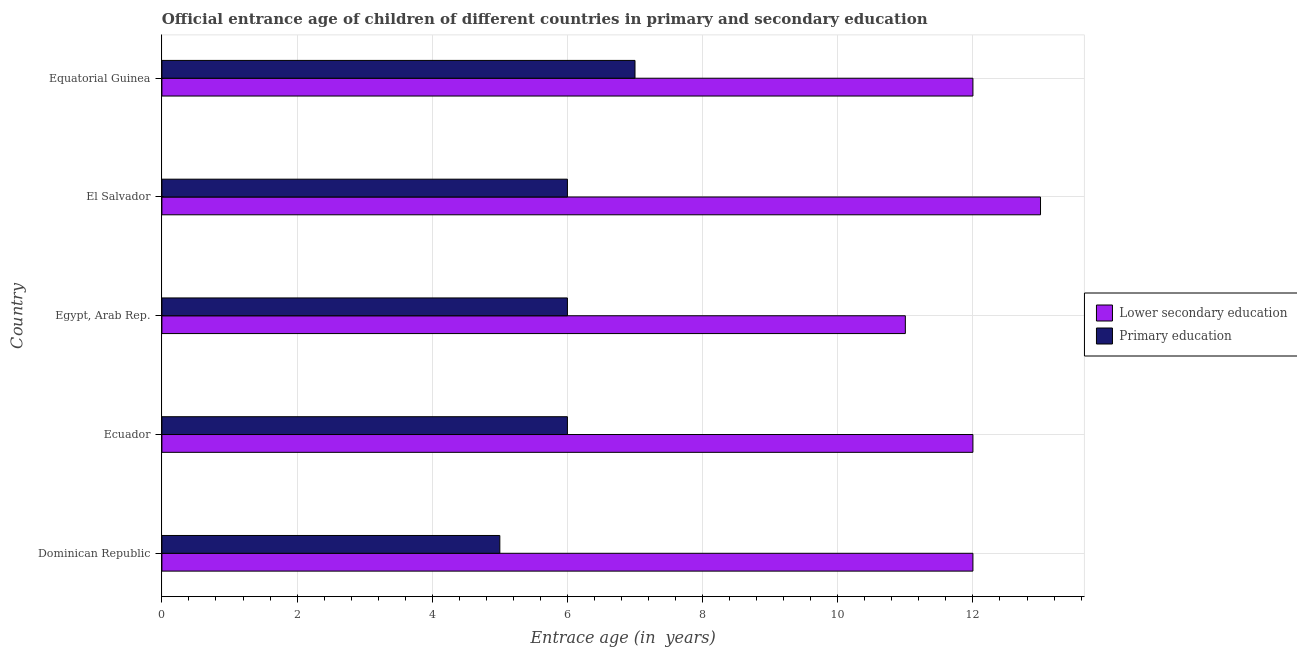How many different coloured bars are there?
Make the answer very short. 2. Are the number of bars on each tick of the Y-axis equal?
Your answer should be very brief. Yes. How many bars are there on the 3rd tick from the top?
Give a very brief answer. 2. How many bars are there on the 4th tick from the bottom?
Provide a short and direct response. 2. What is the label of the 3rd group of bars from the top?
Your response must be concise. Egypt, Arab Rep. What is the entrance age of chiildren in primary education in Equatorial Guinea?
Ensure brevity in your answer.  7. Across all countries, what is the maximum entrance age of chiildren in primary education?
Your answer should be very brief. 7. Across all countries, what is the minimum entrance age of chiildren in primary education?
Your answer should be very brief. 5. In which country was the entrance age of chiildren in primary education maximum?
Provide a short and direct response. Equatorial Guinea. In which country was the entrance age of chiildren in primary education minimum?
Give a very brief answer. Dominican Republic. What is the total entrance age of chiildren in primary education in the graph?
Give a very brief answer. 30. What is the difference between the entrance age of children in lower secondary education in Ecuador and that in El Salvador?
Provide a succinct answer. -1. What is the difference between the entrance age of chiildren in primary education in Equatorial Guinea and the entrance age of children in lower secondary education in El Salvador?
Ensure brevity in your answer.  -6. What is the difference between the entrance age of chiildren in primary education and entrance age of children in lower secondary education in Equatorial Guinea?
Make the answer very short. -5. What is the ratio of the entrance age of chiildren in primary education in Egypt, Arab Rep. to that in Equatorial Guinea?
Make the answer very short. 0.86. Is the entrance age of children in lower secondary education in El Salvador less than that in Equatorial Guinea?
Provide a short and direct response. No. Is the difference between the entrance age of chiildren in primary education in Ecuador and El Salvador greater than the difference between the entrance age of children in lower secondary education in Ecuador and El Salvador?
Keep it short and to the point. Yes. What is the difference between the highest and the lowest entrance age of children in lower secondary education?
Offer a very short reply. 2. What does the 1st bar from the top in Egypt, Arab Rep. represents?
Your response must be concise. Primary education. What does the 1st bar from the bottom in El Salvador represents?
Your answer should be very brief. Lower secondary education. How many bars are there?
Keep it short and to the point. 10. Are the values on the major ticks of X-axis written in scientific E-notation?
Your answer should be very brief. No. Does the graph contain any zero values?
Provide a short and direct response. No. Does the graph contain grids?
Offer a very short reply. Yes. How many legend labels are there?
Make the answer very short. 2. What is the title of the graph?
Make the answer very short. Official entrance age of children of different countries in primary and secondary education. What is the label or title of the X-axis?
Make the answer very short. Entrace age (in  years). What is the Entrace age (in  years) in Lower secondary education in Dominican Republic?
Provide a short and direct response. 12. What is the Entrace age (in  years) in Primary education in Dominican Republic?
Your answer should be compact. 5. What is the Entrace age (in  years) in Primary education in Ecuador?
Your answer should be compact. 6. What is the Entrace age (in  years) of Primary education in Egypt, Arab Rep.?
Make the answer very short. 6. What is the Entrace age (in  years) in Primary education in El Salvador?
Provide a short and direct response. 6. What is the Entrace age (in  years) of Lower secondary education in Equatorial Guinea?
Offer a terse response. 12. What is the Entrace age (in  years) in Primary education in Equatorial Guinea?
Make the answer very short. 7. What is the total Entrace age (in  years) in Lower secondary education in the graph?
Make the answer very short. 60. What is the difference between the Entrace age (in  years) of Lower secondary education in Dominican Republic and that in Ecuador?
Your answer should be compact. 0. What is the difference between the Entrace age (in  years) in Lower secondary education in Ecuador and that in Egypt, Arab Rep.?
Your response must be concise. 1. What is the difference between the Entrace age (in  years) of Lower secondary education in Ecuador and that in El Salvador?
Offer a very short reply. -1. What is the difference between the Entrace age (in  years) in Primary education in Egypt, Arab Rep. and that in El Salvador?
Give a very brief answer. 0. What is the difference between the Entrace age (in  years) in Lower secondary education in El Salvador and that in Equatorial Guinea?
Offer a terse response. 1. What is the difference between the Entrace age (in  years) of Lower secondary education in Dominican Republic and the Entrace age (in  years) of Primary education in El Salvador?
Offer a very short reply. 6. What is the difference between the Entrace age (in  years) in Lower secondary education in Ecuador and the Entrace age (in  years) in Primary education in Equatorial Guinea?
Make the answer very short. 5. What is the difference between the Entrace age (in  years) of Lower secondary education in Egypt, Arab Rep. and the Entrace age (in  years) of Primary education in El Salvador?
Provide a short and direct response. 5. What is the difference between the Entrace age (in  years) of Lower secondary education in Egypt, Arab Rep. and the Entrace age (in  years) of Primary education in Equatorial Guinea?
Your answer should be very brief. 4. What is the difference between the Entrace age (in  years) of Lower secondary education in El Salvador and the Entrace age (in  years) of Primary education in Equatorial Guinea?
Give a very brief answer. 6. What is the average Entrace age (in  years) in Lower secondary education per country?
Provide a succinct answer. 12. What is the difference between the Entrace age (in  years) in Lower secondary education and Entrace age (in  years) in Primary education in Egypt, Arab Rep.?
Provide a succinct answer. 5. What is the ratio of the Entrace age (in  years) in Lower secondary education in Dominican Republic to that in Ecuador?
Offer a very short reply. 1. What is the ratio of the Entrace age (in  years) of Primary education in Dominican Republic to that in Ecuador?
Give a very brief answer. 0.83. What is the ratio of the Entrace age (in  years) of Lower secondary education in Dominican Republic to that in Egypt, Arab Rep.?
Give a very brief answer. 1.09. What is the ratio of the Entrace age (in  years) of Primary education in Dominican Republic to that in Egypt, Arab Rep.?
Keep it short and to the point. 0.83. What is the ratio of the Entrace age (in  years) of Lower secondary education in Dominican Republic to that in El Salvador?
Your answer should be very brief. 0.92. What is the ratio of the Entrace age (in  years) in Primary education in Dominican Republic to that in El Salvador?
Keep it short and to the point. 0.83. What is the ratio of the Entrace age (in  years) in Lower secondary education in Ecuador to that in El Salvador?
Ensure brevity in your answer.  0.92. What is the ratio of the Entrace age (in  years) of Primary education in Ecuador to that in El Salvador?
Provide a succinct answer. 1. What is the ratio of the Entrace age (in  years) in Lower secondary education in Ecuador to that in Equatorial Guinea?
Ensure brevity in your answer.  1. What is the ratio of the Entrace age (in  years) in Lower secondary education in Egypt, Arab Rep. to that in El Salvador?
Ensure brevity in your answer.  0.85. What is the ratio of the Entrace age (in  years) in Primary education in Egypt, Arab Rep. to that in El Salvador?
Provide a succinct answer. 1. What is the ratio of the Entrace age (in  years) in Lower secondary education in Egypt, Arab Rep. to that in Equatorial Guinea?
Offer a very short reply. 0.92. What is the ratio of the Entrace age (in  years) of Primary education in Egypt, Arab Rep. to that in Equatorial Guinea?
Ensure brevity in your answer.  0.86. What is the ratio of the Entrace age (in  years) of Lower secondary education in El Salvador to that in Equatorial Guinea?
Offer a very short reply. 1.08. What is the difference between the highest and the second highest Entrace age (in  years) of Primary education?
Give a very brief answer. 1. 